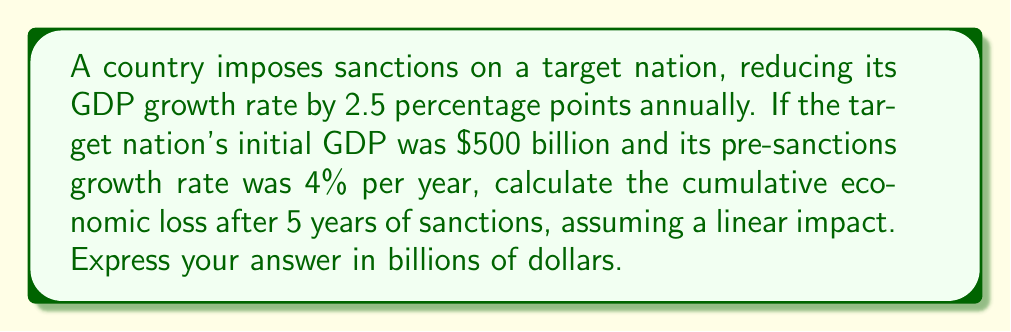Teach me how to tackle this problem. Let's approach this step-by-step:

1) First, we need to calculate the GDP growth without sanctions:
   $$ GDP_{without\_sanctions} = 500 \cdot (1 + 0.04)^5 $$
   $$ = 500 \cdot 1.04^5 = 500 \cdot 1.2166 = 608.3 \text{ billion} $$

2) Now, let's calculate the GDP growth with sanctions:
   The new growth rate is 4% - 2.5% = 1.5%
   $$ GDP_{with\_sanctions} = 500 \cdot (1 + 0.015)^5 $$
   $$ = 500 \cdot 1.015^5 = 500 \cdot 1.0773 = 538.65 \text{ billion} $$

3) The cumulative economic loss is the difference between these two values:
   $$ Loss = GDP_{without\_sanctions} - GDP_{with\_sanctions} $$
   $$ = 608.3 - 538.65 = 69.65 \text{ billion} $$

Therefore, the cumulative economic loss after 5 years of sanctions is $69.65 billion.
Answer: $69.65 billion 